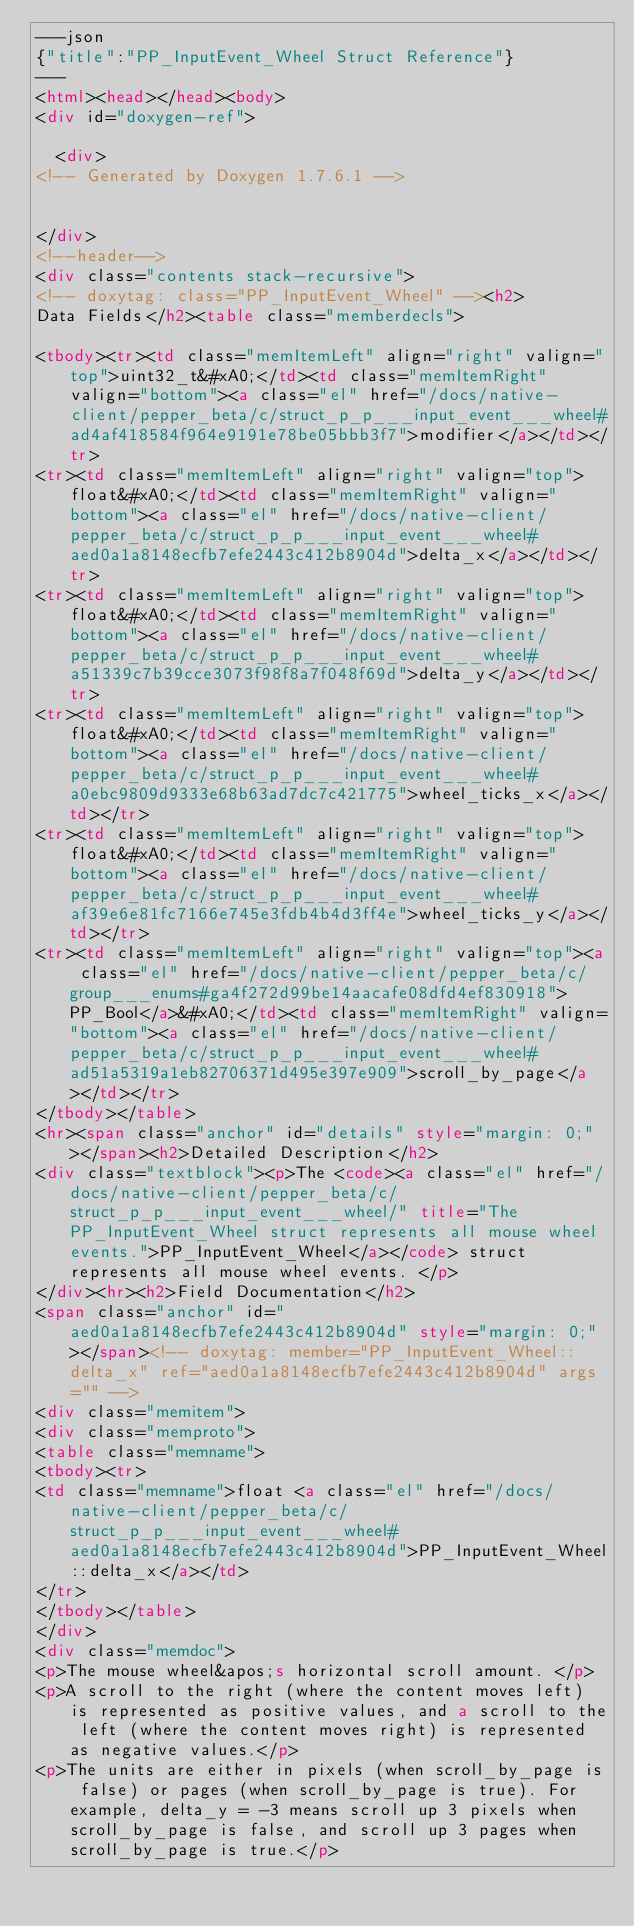<code> <loc_0><loc_0><loc_500><loc_500><_HTML_>---json
{"title":"PP_InputEvent_Wheel Struct Reference"}
---
<html><head></head><body>
<div id="doxygen-ref">

  <div>
<!-- Generated by Doxygen 1.7.6.1 -->


</div>
<!--header-->
<div class="contents stack-recursive">
<!-- doxytag: class="PP_InputEvent_Wheel" --><h2>
Data Fields</h2><table class="memberdecls">

<tbody><tr><td class="memItemLeft" align="right" valign="top">uint32_t&#xA0;</td><td class="memItemRight" valign="bottom"><a class="el" href="/docs/native-client/pepper_beta/c/struct_p_p___input_event___wheel#ad4af418584f964e9191e78be05bbb3f7">modifier</a></td></tr>
<tr><td class="memItemLeft" align="right" valign="top">float&#xA0;</td><td class="memItemRight" valign="bottom"><a class="el" href="/docs/native-client/pepper_beta/c/struct_p_p___input_event___wheel#aed0a1a8148ecfb7efe2443c412b8904d">delta_x</a></td></tr>
<tr><td class="memItemLeft" align="right" valign="top">float&#xA0;</td><td class="memItemRight" valign="bottom"><a class="el" href="/docs/native-client/pepper_beta/c/struct_p_p___input_event___wheel#a51339c7b39cce3073f98f8a7f048f69d">delta_y</a></td></tr>
<tr><td class="memItemLeft" align="right" valign="top">float&#xA0;</td><td class="memItemRight" valign="bottom"><a class="el" href="/docs/native-client/pepper_beta/c/struct_p_p___input_event___wheel#a0ebc9809d9333e68b63ad7dc7c421775">wheel_ticks_x</a></td></tr>
<tr><td class="memItemLeft" align="right" valign="top">float&#xA0;</td><td class="memItemRight" valign="bottom"><a class="el" href="/docs/native-client/pepper_beta/c/struct_p_p___input_event___wheel#af39e6e81fc7166e745e3fdb4b4d3ff4e">wheel_ticks_y</a></td></tr>
<tr><td class="memItemLeft" align="right" valign="top"><a class="el" href="/docs/native-client/pepper_beta/c/group___enums#ga4f272d99be14aacafe08dfd4ef830918">PP_Bool</a>&#xA0;</td><td class="memItemRight" valign="bottom"><a class="el" href="/docs/native-client/pepper_beta/c/struct_p_p___input_event___wheel#ad51a5319a1eb82706371d495e397e909">scroll_by_page</a></td></tr>
</tbody></table>
<hr><span class="anchor" id="details" style="margin: 0;"></span><h2>Detailed Description</h2>
<div class="textblock"><p>The <code><a class="el" href="/docs/native-client/pepper_beta/c/struct_p_p___input_event___wheel/" title="The PP_InputEvent_Wheel struct represents all mouse wheel events.">PP_InputEvent_Wheel</a></code> struct represents all mouse wheel events. </p>
</div><hr><h2>Field Documentation</h2>
<span class="anchor" id="aed0a1a8148ecfb7efe2443c412b8904d" style="margin: 0;"></span><!-- doxytag: member="PP_InputEvent_Wheel::delta_x" ref="aed0a1a8148ecfb7efe2443c412b8904d" args="" -->
<div class="memitem">
<div class="memproto">
<table class="memname">
<tbody><tr>
<td class="memname">float <a class="el" href="/docs/native-client/pepper_beta/c/struct_p_p___input_event___wheel#aed0a1a8148ecfb7efe2443c412b8904d">PP_InputEvent_Wheel::delta_x</a></td>
</tr>
</tbody></table>
</div>
<div class="memdoc">
<p>The mouse wheel&apos;s horizontal scroll amount. </p>
<p>A scroll to the right (where the content moves left) is represented as positive values, and a scroll to the left (where the content moves right) is represented as negative values.</p>
<p>The units are either in pixels (when scroll_by_page is false) or pages (when scroll_by_page is true). For example, delta_y = -3 means scroll up 3 pixels when scroll_by_page is false, and scroll up 3 pages when scroll_by_page is true.</p></code> 